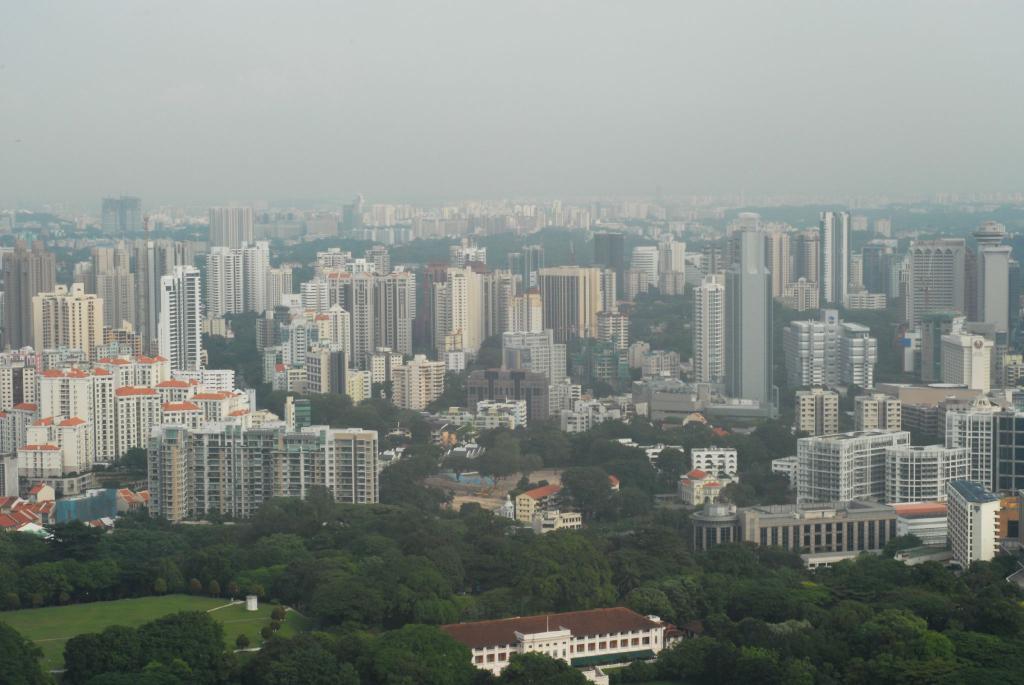Describe this image in one or two sentences. This is an outside view. At the bottom of the image I can see many trees. In the background there are many buildings. On the left bottom of the image there is a ground. At the top I can see the sky. 